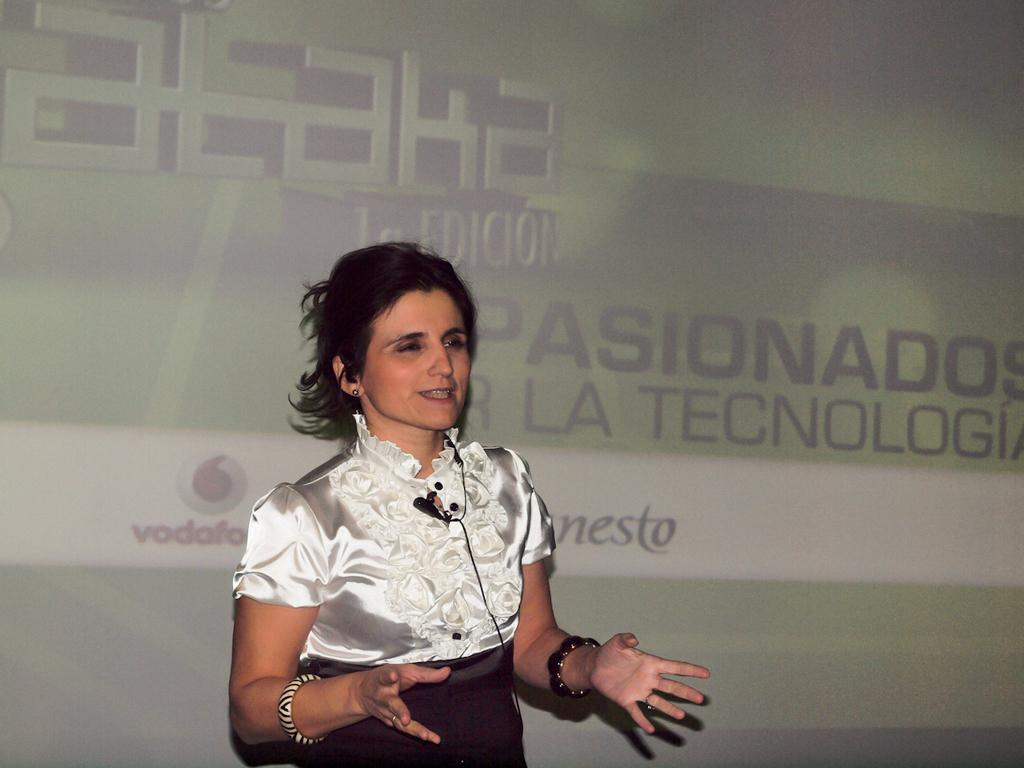Who is present in the image? There is a woman in the image. What is the woman wearing? The woman is wearing a white top. What is the woman doing in the image? The woman's mouth is open, which might suggest she is speaking or singing. What can be seen on the screen in the background of the image? There is text visible on a screen in the background of the image. What type of marble is present on the floor in the image? There is no marble floor visible in the image; it is not mentioned in the provided facts. 